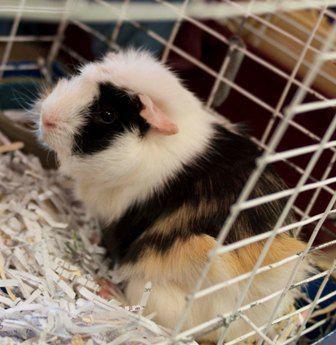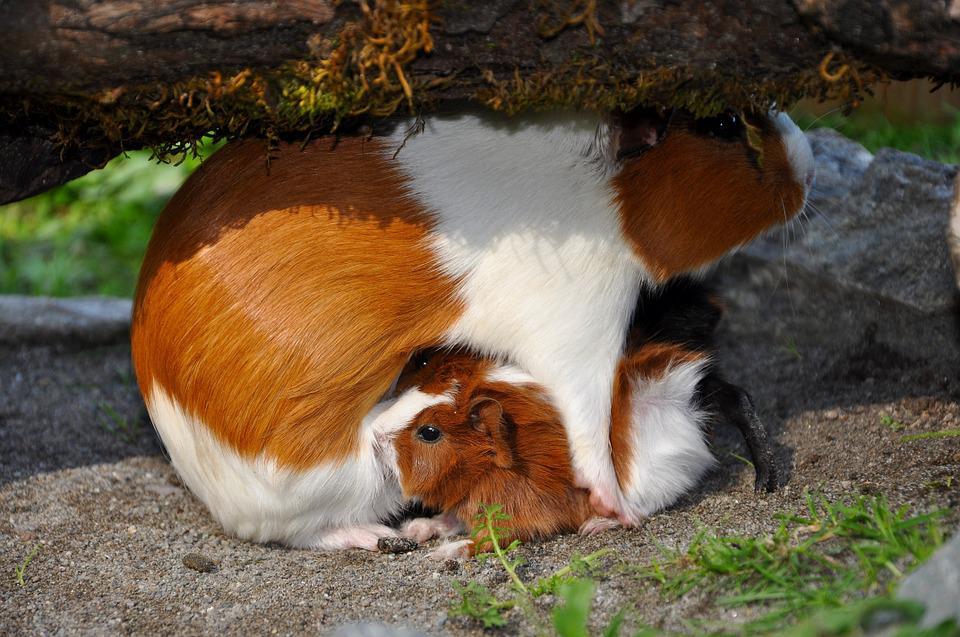The first image is the image on the left, the second image is the image on the right. Examine the images to the left and right. Is the description "One image shows guinea pigs in the corner of an enclosure with plant matter on its floor, and the other image shows a guinea pig by a structure made of side-by-side wood rods." accurate? Answer yes or no. No. The first image is the image on the left, the second image is the image on the right. Assess this claim about the two images: "There are no more than two animals in a wire cage in one of the images.". Correct or not? Answer yes or no. Yes. 